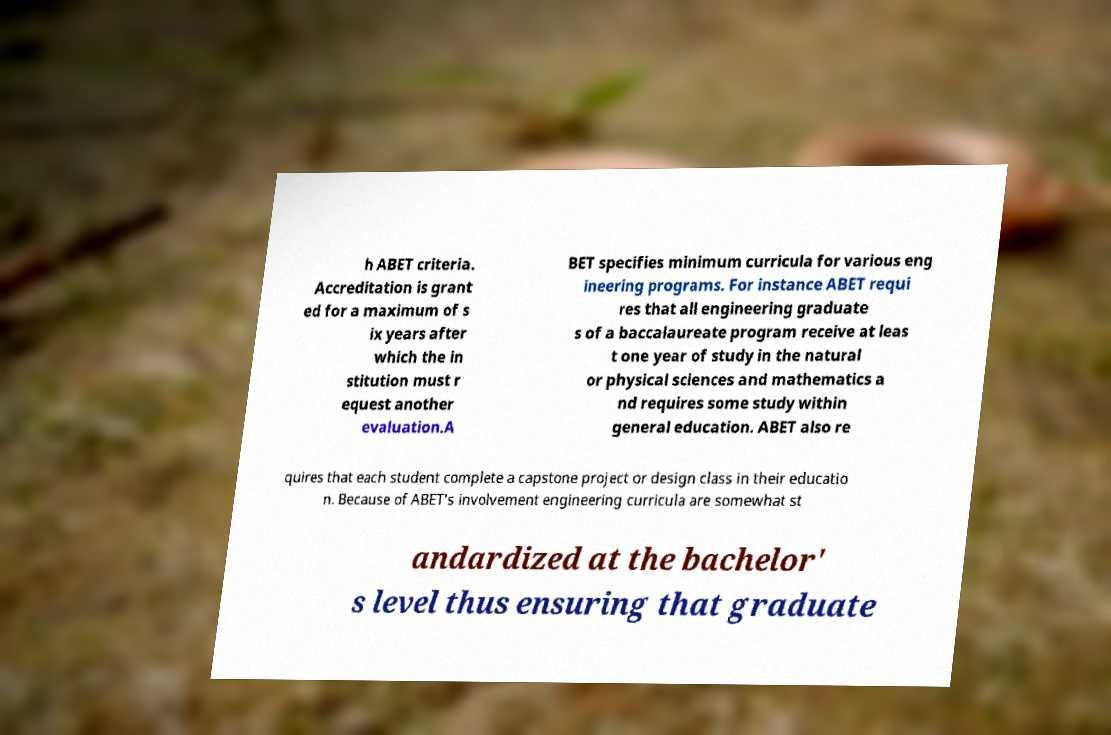Please read and relay the text visible in this image. What does it say? h ABET criteria. Accreditation is grant ed for a maximum of s ix years after which the in stitution must r equest another evaluation.A BET specifies minimum curricula for various eng ineering programs. For instance ABET requi res that all engineering graduate s of a baccalaureate program receive at leas t one year of study in the natural or physical sciences and mathematics a nd requires some study within general education. ABET also re quires that each student complete a capstone project or design class in their educatio n. Because of ABET's involvement engineering curricula are somewhat st andardized at the bachelor' s level thus ensuring that graduate 